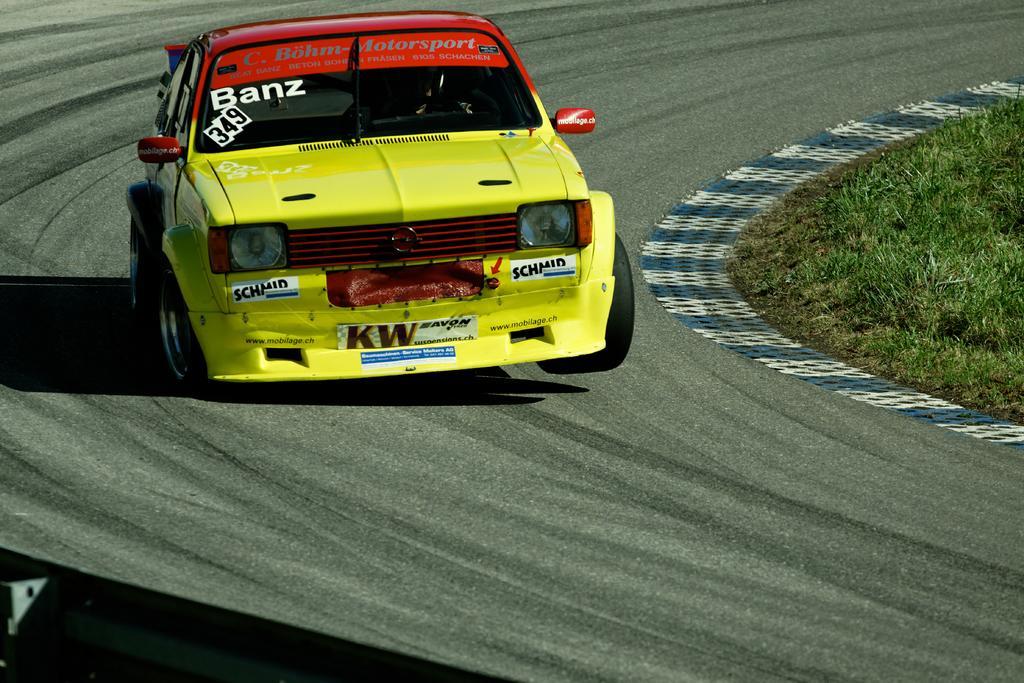Please provide a concise description of this image. In this image there is a car on the track, beside the track there is grass. 